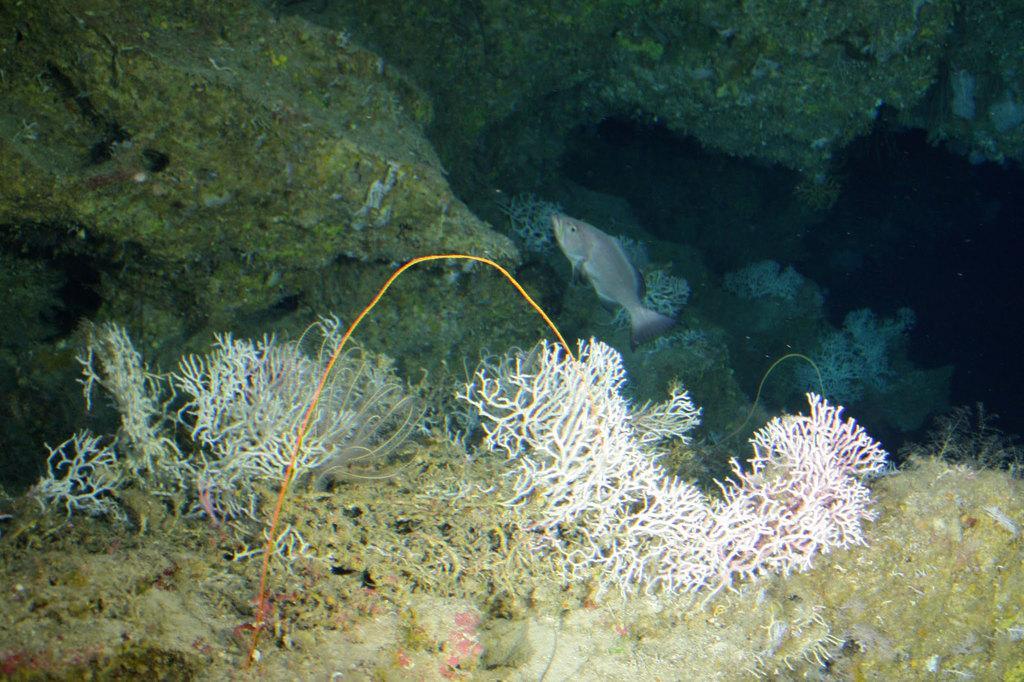How would you summarize this image in a sentence or two? In the center of the image we can see a fish, rocks and corals in the water. 